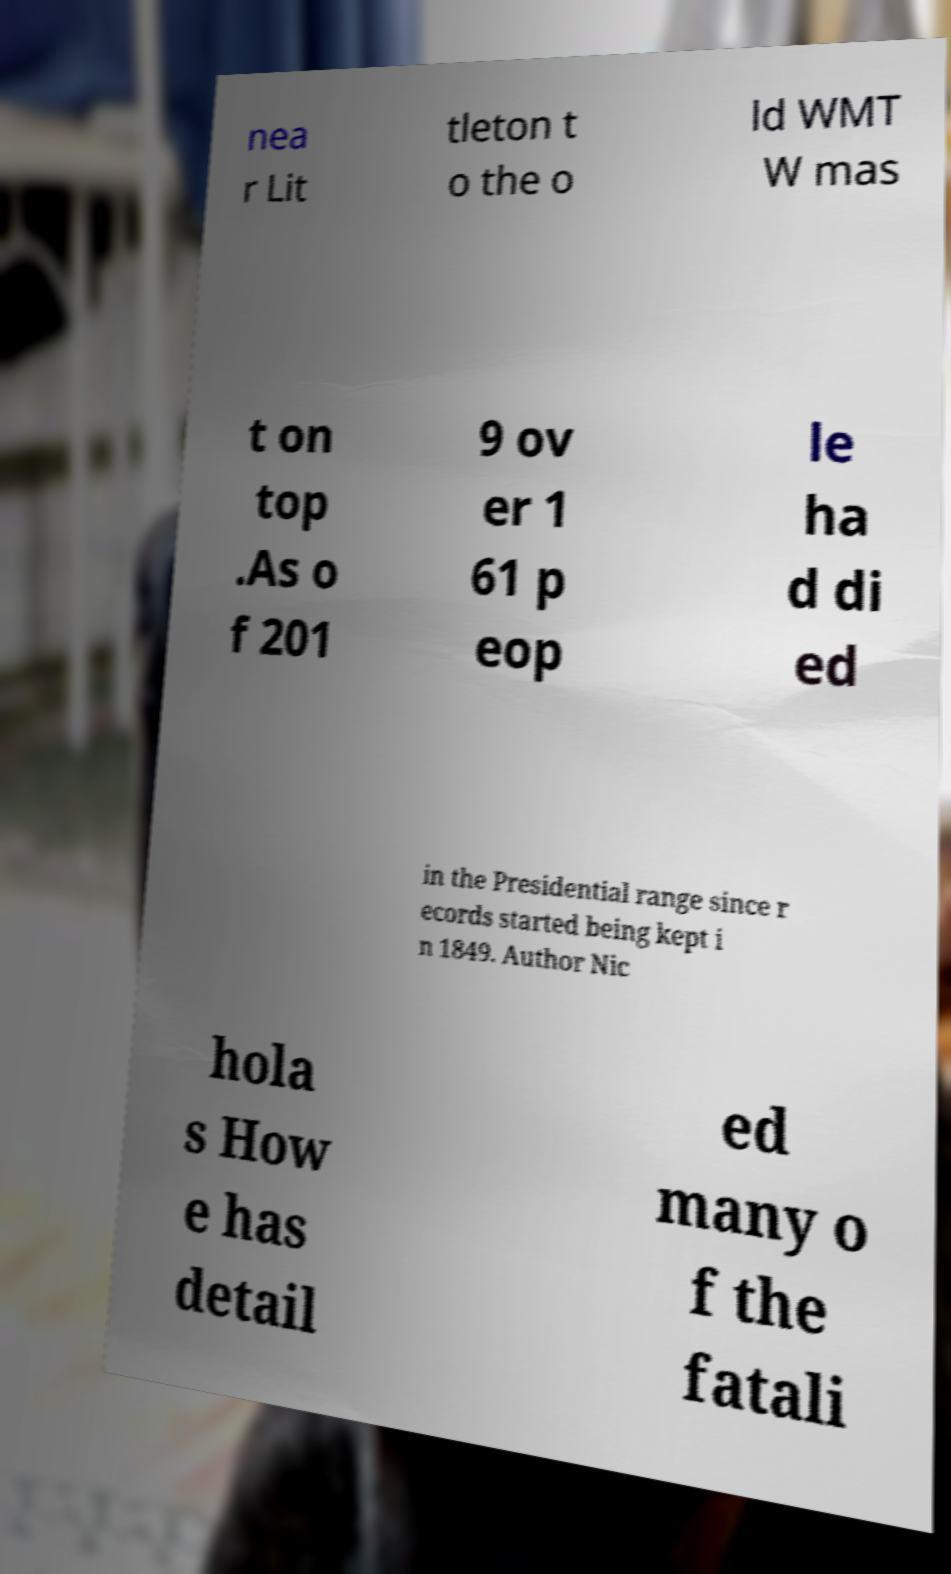For documentation purposes, I need the text within this image transcribed. Could you provide that? nea r Lit tleton t o the o ld WMT W mas t on top .As o f 201 9 ov er 1 61 p eop le ha d di ed in the Presidential range since r ecords started being kept i n 1849. Author Nic hola s How e has detail ed many o f the fatali 